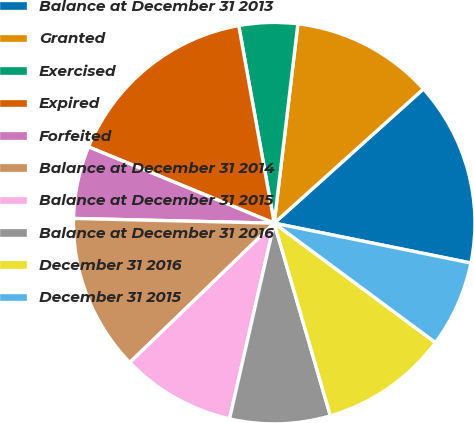Convert chart. <chart><loc_0><loc_0><loc_500><loc_500><pie_chart><fcel>Balance at December 31 2013<fcel>Granted<fcel>Exercised<fcel>Expired<fcel>Forfeited<fcel>Balance at December 31 2014<fcel>Balance at December 31 2015<fcel>Balance at December 31 2016<fcel>December 31 2016<fcel>December 31 2015<nl><fcel>14.84%<fcel>11.46%<fcel>4.71%<fcel>15.97%<fcel>5.83%<fcel>12.59%<fcel>9.21%<fcel>8.09%<fcel>10.34%<fcel>6.96%<nl></chart> 